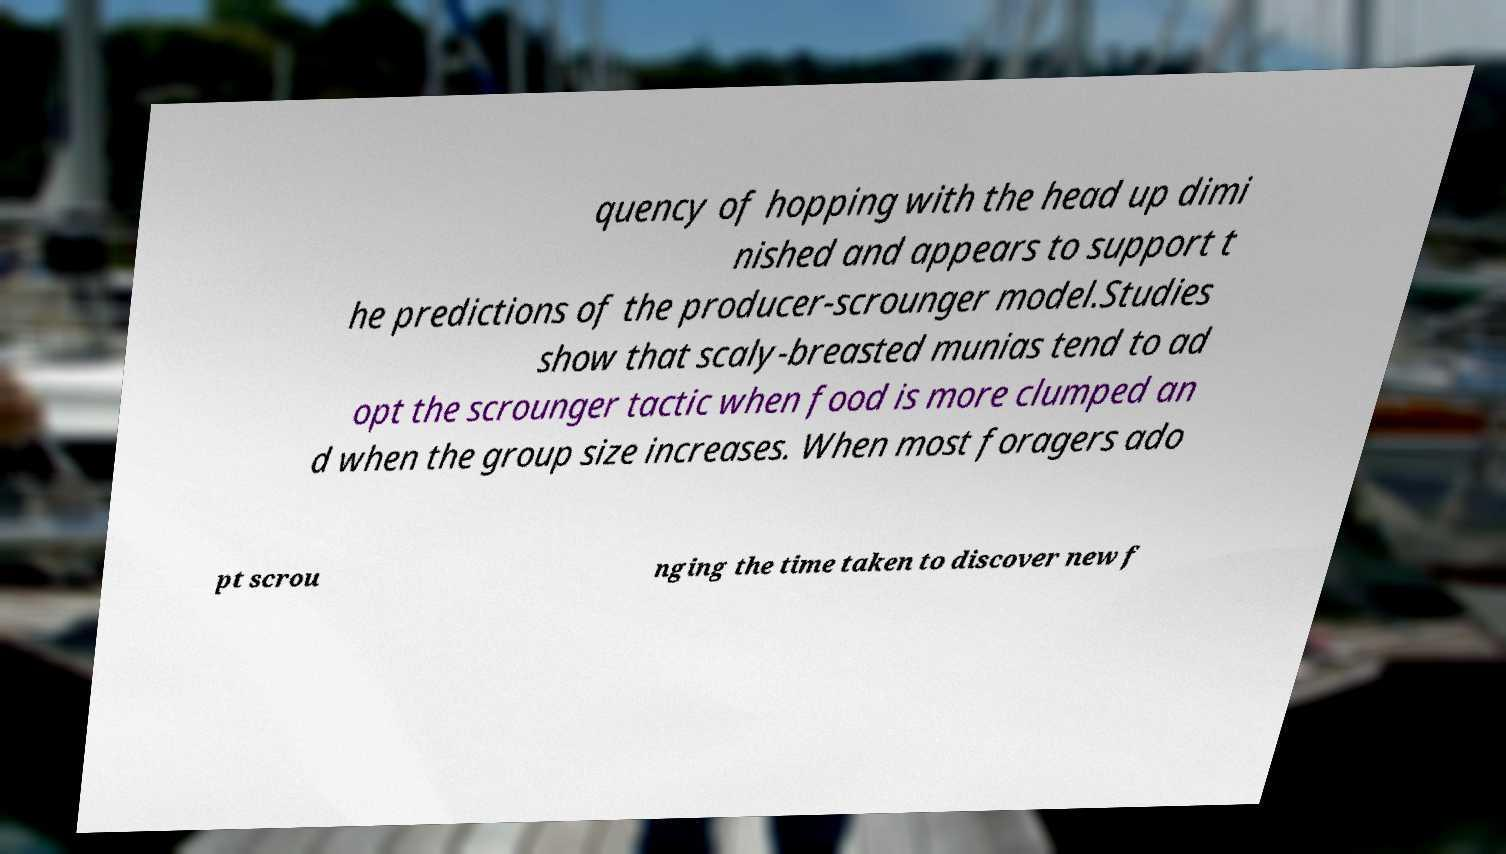Can you read and provide the text displayed in the image?This photo seems to have some interesting text. Can you extract and type it out for me? quency of hopping with the head up dimi nished and appears to support t he predictions of the producer-scrounger model.Studies show that scaly-breasted munias tend to ad opt the scrounger tactic when food is more clumped an d when the group size increases. When most foragers ado pt scrou nging the time taken to discover new f 